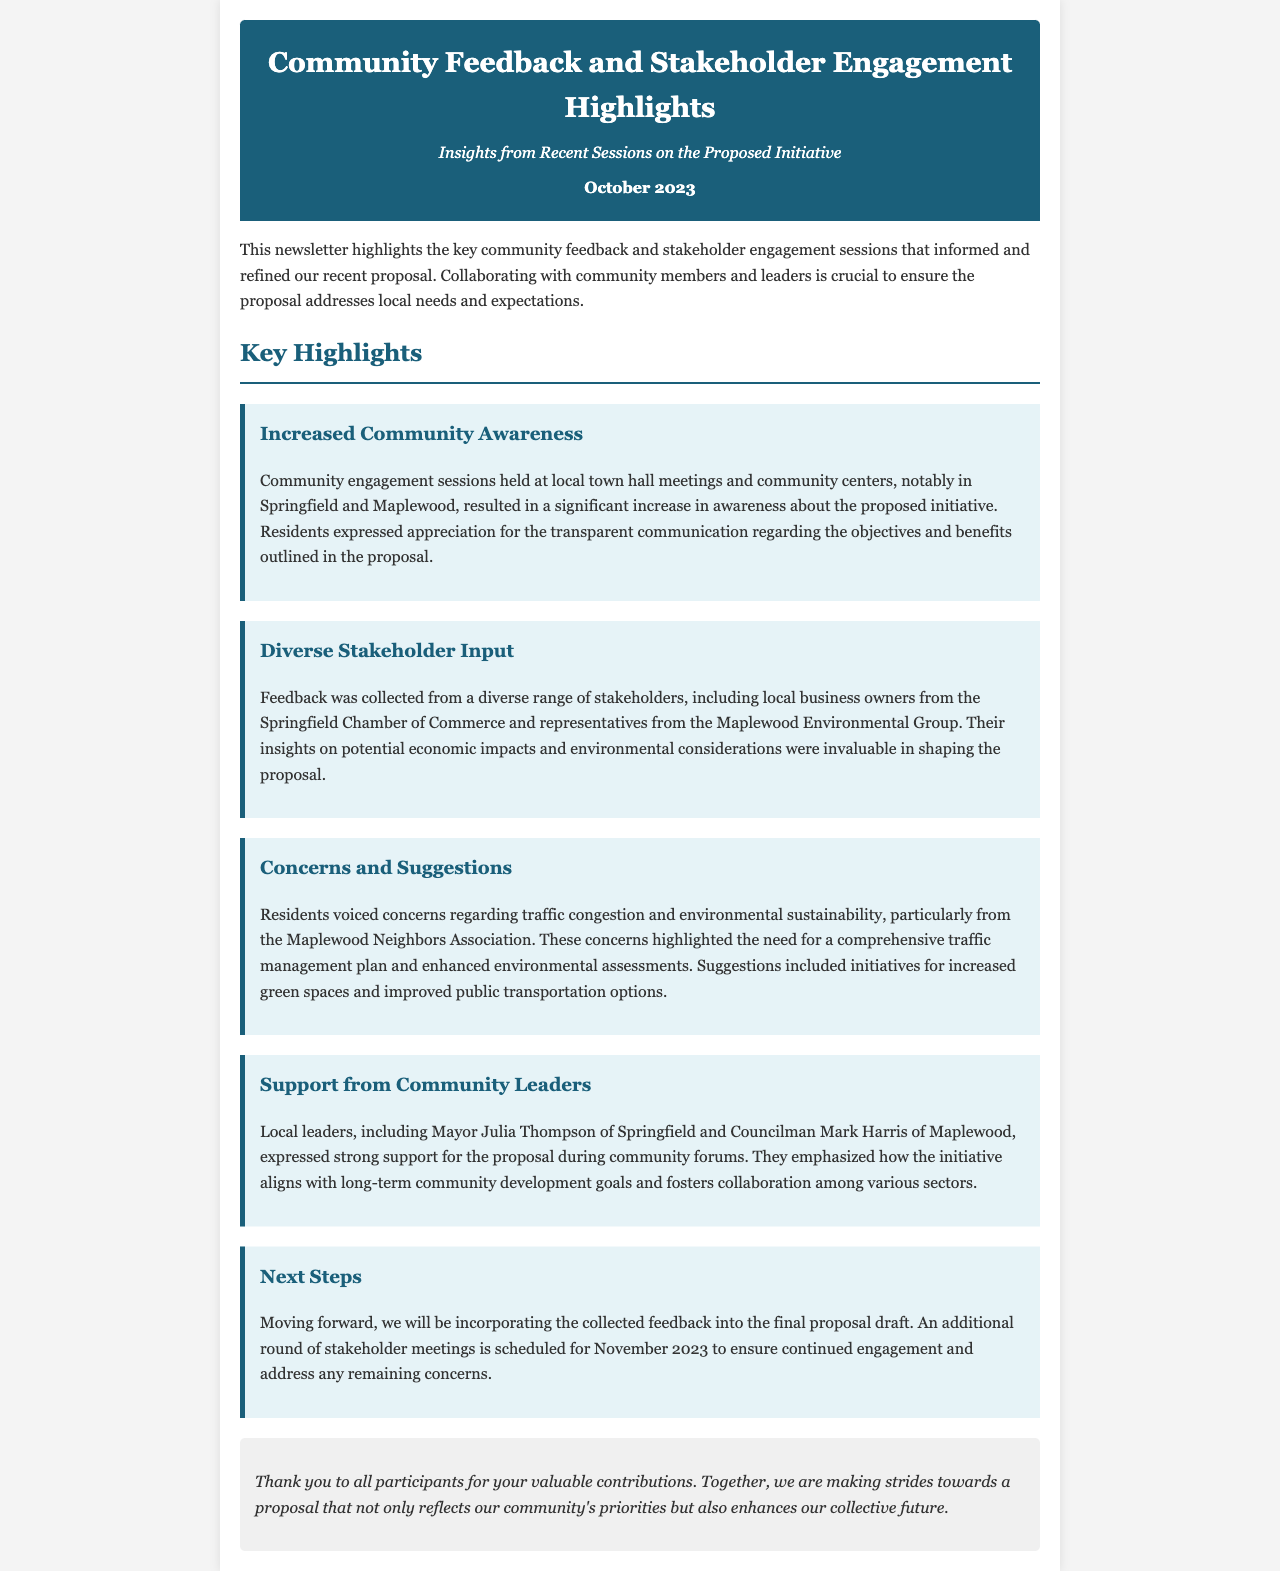What month was the newsletter published? The newsletter mentions the publication date as October 2023.
Answer: October 2023 What is the title of the newsletter? The title of the newsletter is found in the header section.
Answer: Community Feedback and Stakeholder Engagement Highlights Who expressed strong support for the proposal? The newsletter states that local leaders, including Mayor Julia Thompson and Councilman Mark Harris, expressed support.
Answer: Mayor Julia Thompson and Councilman Mark Harris What was a key concern voiced by residents? The document highlights that residents voiced concerns regarding traffic congestion and environmental sustainability.
Answer: Traffic congestion What will happen in November 2023? The newsletter states that an additional round of stakeholder meetings is scheduled for November 2023.
Answer: Additional stakeholder meetings What type of feedback was collected from stakeholders? The document specifies that feedback was collected from a diverse range of stakeholders including local business owners and representatives from environment groups.
Answer: Diverse Stakeholder Input What did residents suggest regarding public transportation? The newsletter mentions that residents suggested improved public transportation options.
Answer: Improved public transportation options How were the sessions held to increase community awareness? The newsletter notes that community engagement sessions were held at local town hall meetings and community centers.
Answer: Town hall meetings and community centers 